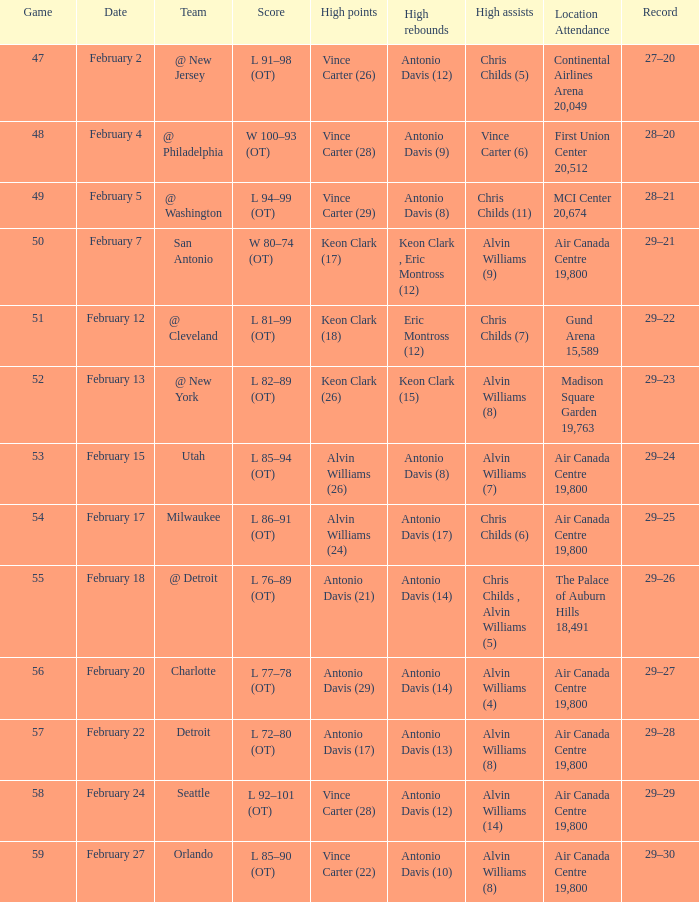What is the Team with a game of more than 56, and the score is l 85–90 (ot)? Orlando. 